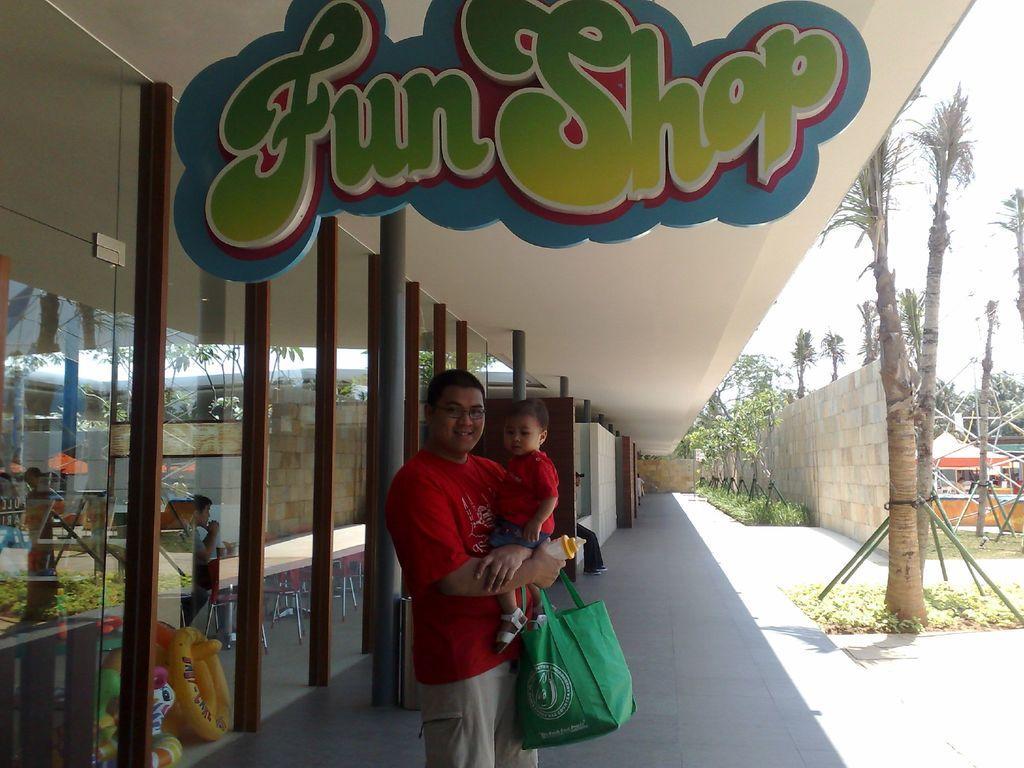Could you give a brief overview of what you see in this image? In the center of the image there is a person standing and holding a baby. On the right side of the image we can see trees, wall, tents. On the left side of the image we can see doors and pillars. 